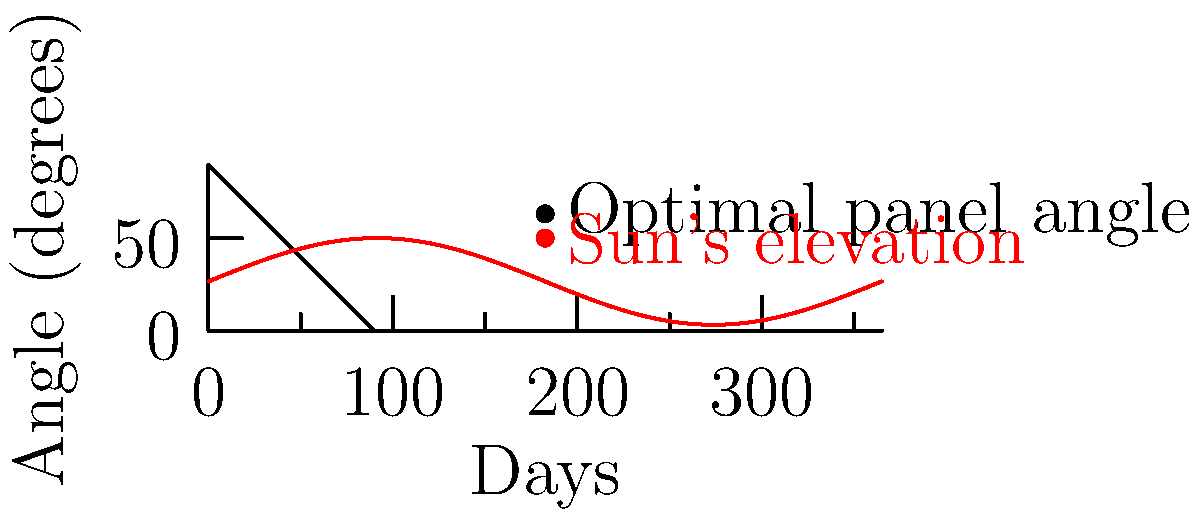A client is interested in installing solar panels on their luxury eco-friendly home in Palm Beach (latitude 26.7°N). Given the sun path chart shown, which depicts the sun's elevation angle throughout the year and the optimal panel angle, what is the best fixed tilt angle for the solar panels to maximize annual energy production? To determine the optimal fixed tilt angle for solar panels in Palm Beach, we need to follow these steps:

1. Understand the latitude: Palm Beach is at 26.7°N latitude.

2. Analyze the sun path chart:
   - The red curve shows the sun's elevation angle throughout the year.
   - The black line represents the optimal panel angle.

3. Interpret the chart:
   - The optimal panel angle is relatively constant throughout the year.
   - It intersects with the sun's elevation angle twice a year, likely during the equinoxes.

4. Calculate the optimal tilt angle:
   - The general rule of thumb for fixed solar panels is to set the tilt angle equal to the latitude of the location.
   - In this case: Optimal tilt angle ≈ 26.7°

5. Verify with the chart:
   - The chart shows the optimal panel angle at around 63.3° from the horizontal.
   - This corresponds to a tilt angle of 90° - 63.3° = 26.7° from the vertical, which matches our calculation.

6. Consider local factors:
   - Palm Beach has a tropical climate with high humidity and occasional storms.
   - A slightly steeper angle (around 30°) might be beneficial for self-cleaning and to reduce the risk of water accumulation.

Therefore, the best fixed tilt angle for solar panels in Palm Beach would be approximately 26.7° to 30° from the horizontal, facing south.
Answer: 26.7° to 30° from horizontal, facing south 